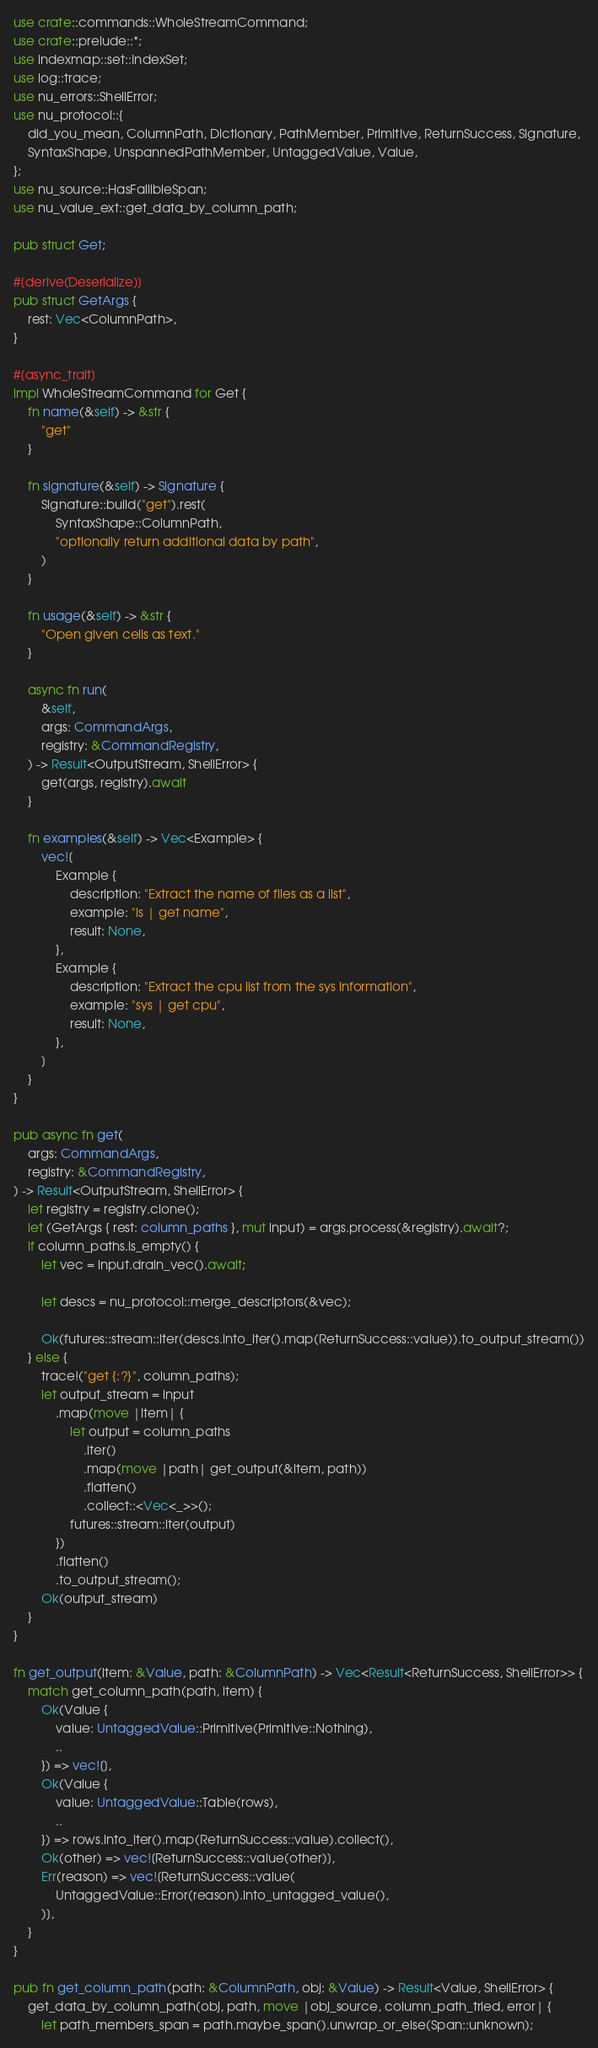Convert code to text. <code><loc_0><loc_0><loc_500><loc_500><_Rust_>use crate::commands::WholeStreamCommand;
use crate::prelude::*;
use indexmap::set::IndexSet;
use log::trace;
use nu_errors::ShellError;
use nu_protocol::{
    did_you_mean, ColumnPath, Dictionary, PathMember, Primitive, ReturnSuccess, Signature,
    SyntaxShape, UnspannedPathMember, UntaggedValue, Value,
};
use nu_source::HasFallibleSpan;
use nu_value_ext::get_data_by_column_path;

pub struct Get;

#[derive(Deserialize)]
pub struct GetArgs {
    rest: Vec<ColumnPath>,
}

#[async_trait]
impl WholeStreamCommand for Get {
    fn name(&self) -> &str {
        "get"
    }

    fn signature(&self) -> Signature {
        Signature::build("get").rest(
            SyntaxShape::ColumnPath,
            "optionally return additional data by path",
        )
    }

    fn usage(&self) -> &str {
        "Open given cells as text."
    }

    async fn run(
        &self,
        args: CommandArgs,
        registry: &CommandRegistry,
    ) -> Result<OutputStream, ShellError> {
        get(args, registry).await
    }

    fn examples(&self) -> Vec<Example> {
        vec![
            Example {
                description: "Extract the name of files as a list",
                example: "ls | get name",
                result: None,
            },
            Example {
                description: "Extract the cpu list from the sys information",
                example: "sys | get cpu",
                result: None,
            },
        ]
    }
}

pub async fn get(
    args: CommandArgs,
    registry: &CommandRegistry,
) -> Result<OutputStream, ShellError> {
    let registry = registry.clone();
    let (GetArgs { rest: column_paths }, mut input) = args.process(&registry).await?;
    if column_paths.is_empty() {
        let vec = input.drain_vec().await;

        let descs = nu_protocol::merge_descriptors(&vec);

        Ok(futures::stream::iter(descs.into_iter().map(ReturnSuccess::value)).to_output_stream())
    } else {
        trace!("get {:?}", column_paths);
        let output_stream = input
            .map(move |item| {
                let output = column_paths
                    .iter()
                    .map(move |path| get_output(&item, path))
                    .flatten()
                    .collect::<Vec<_>>();
                futures::stream::iter(output)
            })
            .flatten()
            .to_output_stream();
        Ok(output_stream)
    }
}

fn get_output(item: &Value, path: &ColumnPath) -> Vec<Result<ReturnSuccess, ShellError>> {
    match get_column_path(path, item) {
        Ok(Value {
            value: UntaggedValue::Primitive(Primitive::Nothing),
            ..
        }) => vec![],
        Ok(Value {
            value: UntaggedValue::Table(rows),
            ..
        }) => rows.into_iter().map(ReturnSuccess::value).collect(),
        Ok(other) => vec![ReturnSuccess::value(other)],
        Err(reason) => vec![ReturnSuccess::value(
            UntaggedValue::Error(reason).into_untagged_value(),
        )],
    }
}

pub fn get_column_path(path: &ColumnPath, obj: &Value) -> Result<Value, ShellError> {
    get_data_by_column_path(obj, path, move |obj_source, column_path_tried, error| {
        let path_members_span = path.maybe_span().unwrap_or_else(Span::unknown);
</code> 